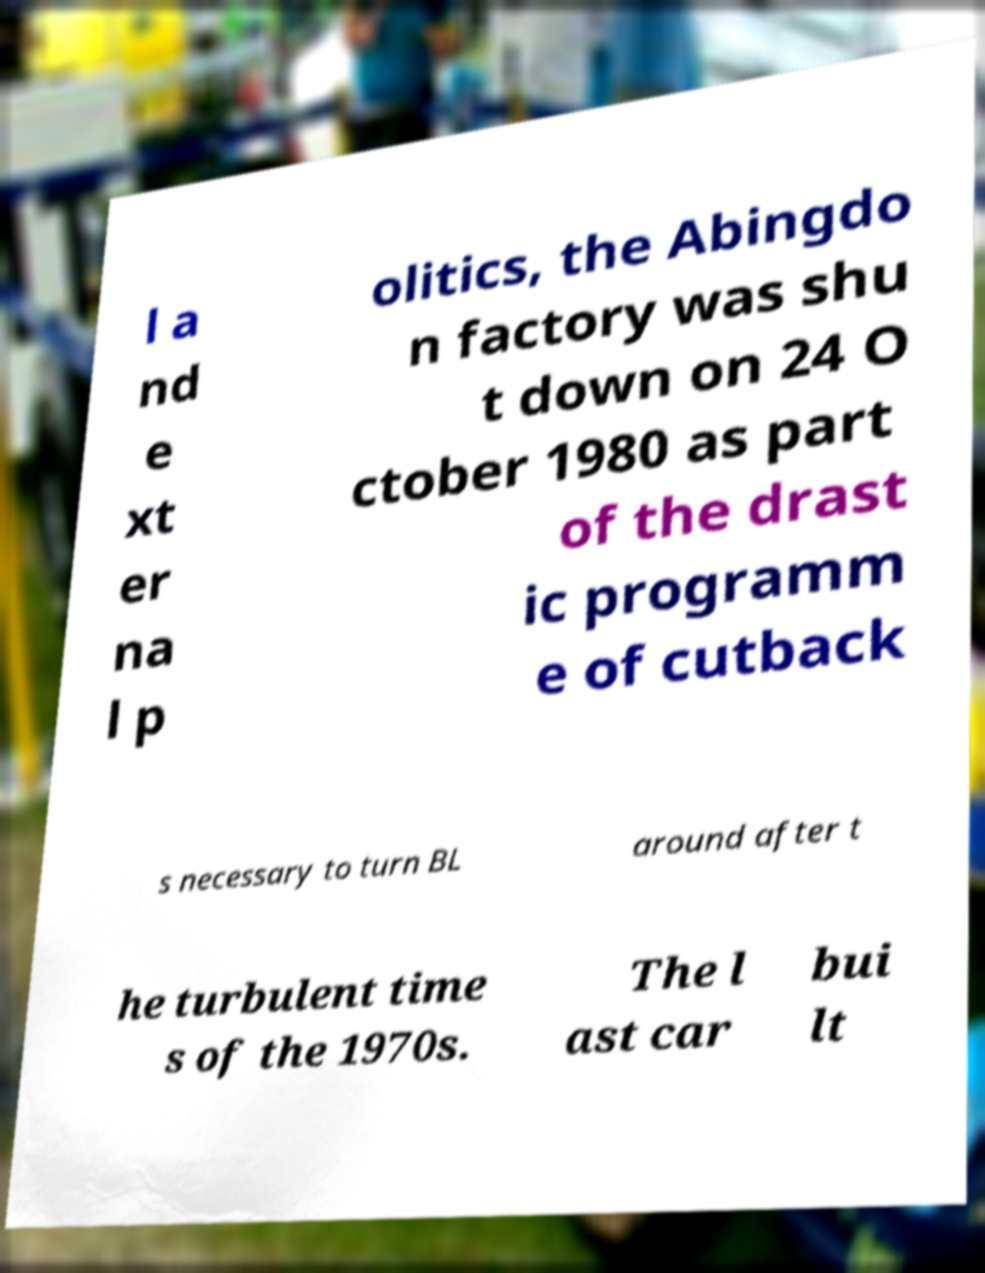Please read and relay the text visible in this image. What does it say? l a nd e xt er na l p olitics, the Abingdo n factory was shu t down on 24 O ctober 1980 as part of the drast ic programm e of cutback s necessary to turn BL around after t he turbulent time s of the 1970s. The l ast car bui lt 